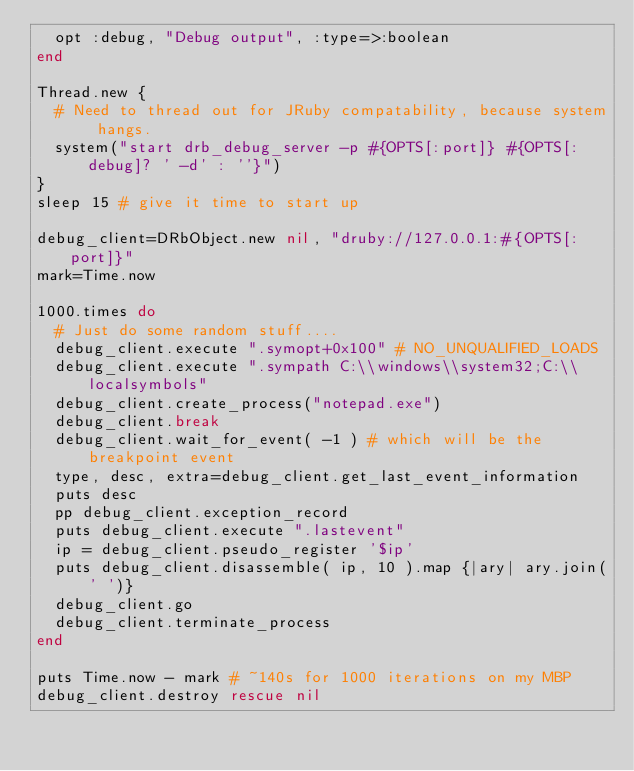<code> <loc_0><loc_0><loc_500><loc_500><_Ruby_>  opt :debug, "Debug output", :type=>:boolean
end

Thread.new {
  # Need to thread out for JRuby compatability, because system hangs.
  system("start drb_debug_server -p #{OPTS[:port]} #{OPTS[:debug]? ' -d' : ''}")
}
sleep 15 # give it time to start up

debug_client=DRbObject.new nil, "druby://127.0.0.1:#{OPTS[:port]}"
mark=Time.now

1000.times do
  # Just do some random stuff....
  debug_client.execute ".symopt+0x100" # NO_UNQUALIFIED_LOADS
  debug_client.execute ".sympath C:\\windows\\system32;C:\\localsymbols"
  debug_client.create_process("notepad.exe")
  debug_client.break
  debug_client.wait_for_event( -1 ) # which will be the breakpoint event
  type, desc, extra=debug_client.get_last_event_information
  puts desc
  pp debug_client.exception_record
  puts debug_client.execute ".lastevent"
  ip = debug_client.pseudo_register '$ip'
  puts debug_client.disassemble( ip, 10 ).map {|ary| ary.join(' ')}
  debug_client.go
  debug_client.terminate_process
end

puts Time.now - mark # ~140s for 1000 iterations on my MBP
debug_client.destroy rescue nil
</code> 